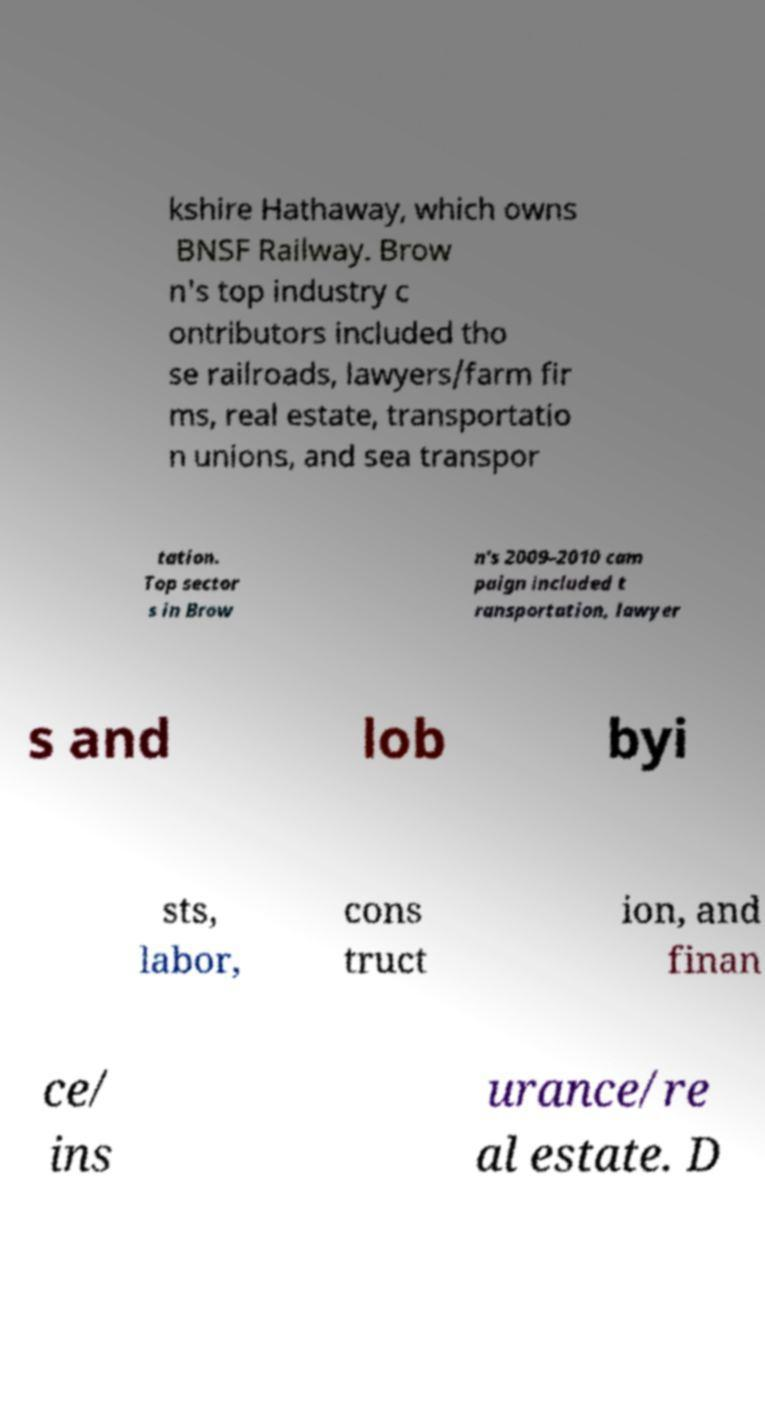Can you read and provide the text displayed in the image?This photo seems to have some interesting text. Can you extract and type it out for me? kshire Hathaway, which owns BNSF Railway. Brow n's top industry c ontributors included tho se railroads, lawyers/farm fir ms, real estate, transportatio n unions, and sea transpor tation. Top sector s in Brow n's 2009–2010 cam paign included t ransportation, lawyer s and lob byi sts, labor, cons truct ion, and finan ce/ ins urance/re al estate. D 